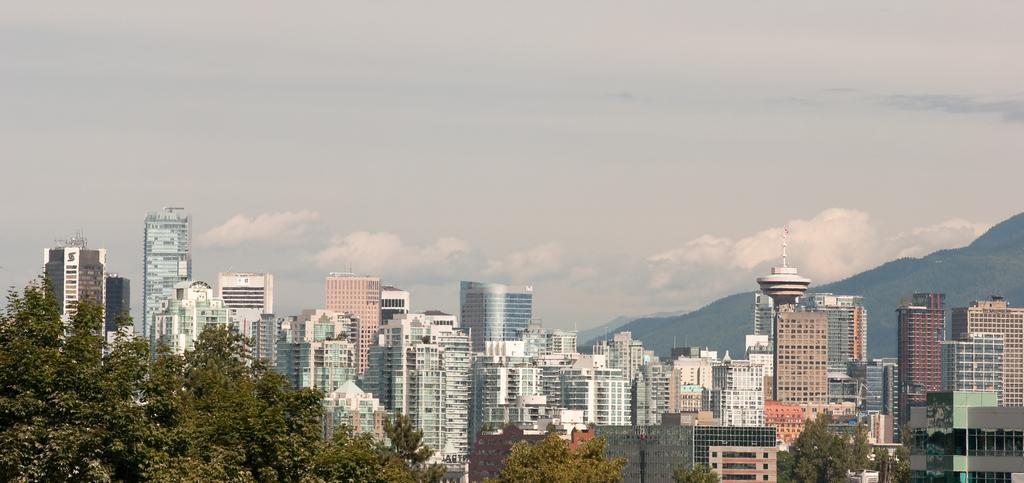What type of structures can be seen in the image? There are buildings in the image. What natural elements are present in the image? There are trees and mountains in the image. What part of the natural environment is visible in the image? The ground is visible in the image. What is visible in the sky in the image? There are clouds in the sky. Can you hear the canvas coughing in the image? There is no canvas or coughing sound present in the image. 